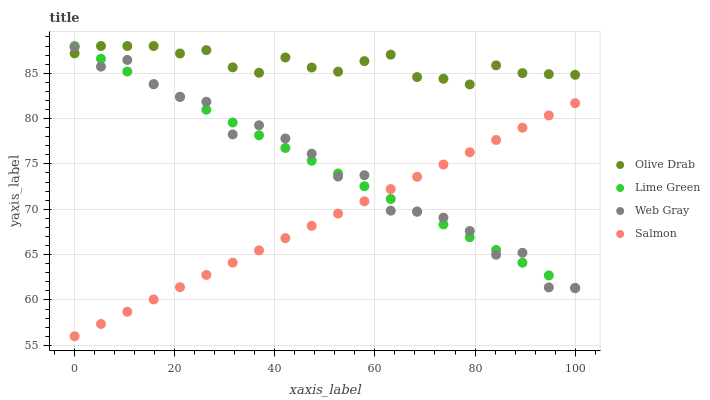Does Salmon have the minimum area under the curve?
Answer yes or no. Yes. Does Olive Drab have the maximum area under the curve?
Answer yes or no. Yes. Does Web Gray have the minimum area under the curve?
Answer yes or no. No. Does Web Gray have the maximum area under the curve?
Answer yes or no. No. Is Salmon the smoothest?
Answer yes or no. Yes. Is Web Gray the roughest?
Answer yes or no. Yes. Is Lime Green the smoothest?
Answer yes or no. No. Is Lime Green the roughest?
Answer yes or no. No. Does Salmon have the lowest value?
Answer yes or no. Yes. Does Web Gray have the lowest value?
Answer yes or no. No. Does Olive Drab have the highest value?
Answer yes or no. Yes. Does Web Gray have the highest value?
Answer yes or no. No. Is Salmon less than Olive Drab?
Answer yes or no. Yes. Is Olive Drab greater than Salmon?
Answer yes or no. Yes. Does Lime Green intersect Web Gray?
Answer yes or no. Yes. Is Lime Green less than Web Gray?
Answer yes or no. No. Is Lime Green greater than Web Gray?
Answer yes or no. No. Does Salmon intersect Olive Drab?
Answer yes or no. No. 